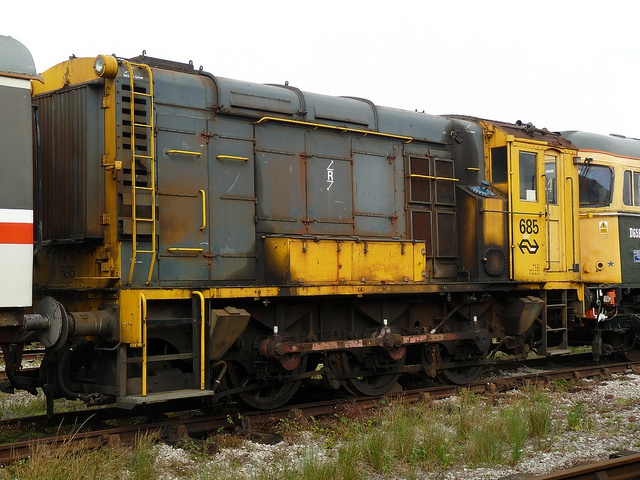Describe the objects in this image and their specific colors. I can see a train in white, black, gray, and orange tones in this image. 